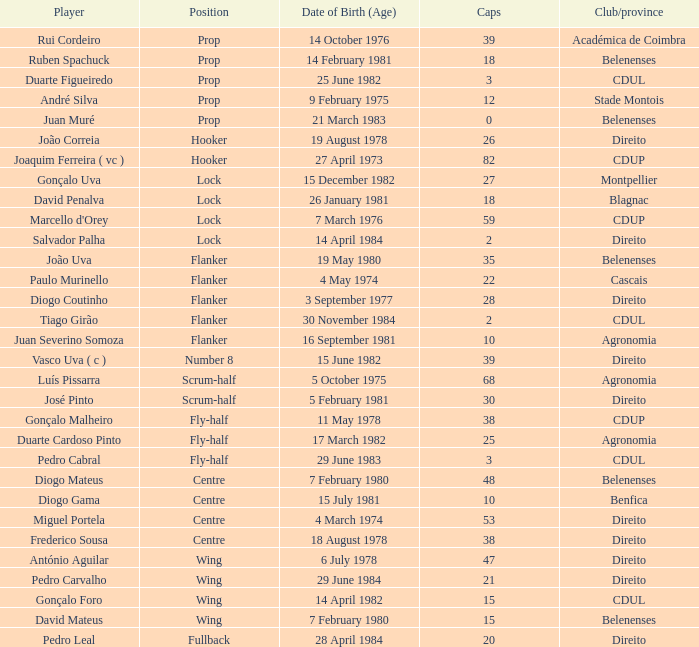Which club/region has a player of david penalva? Blagnac. 